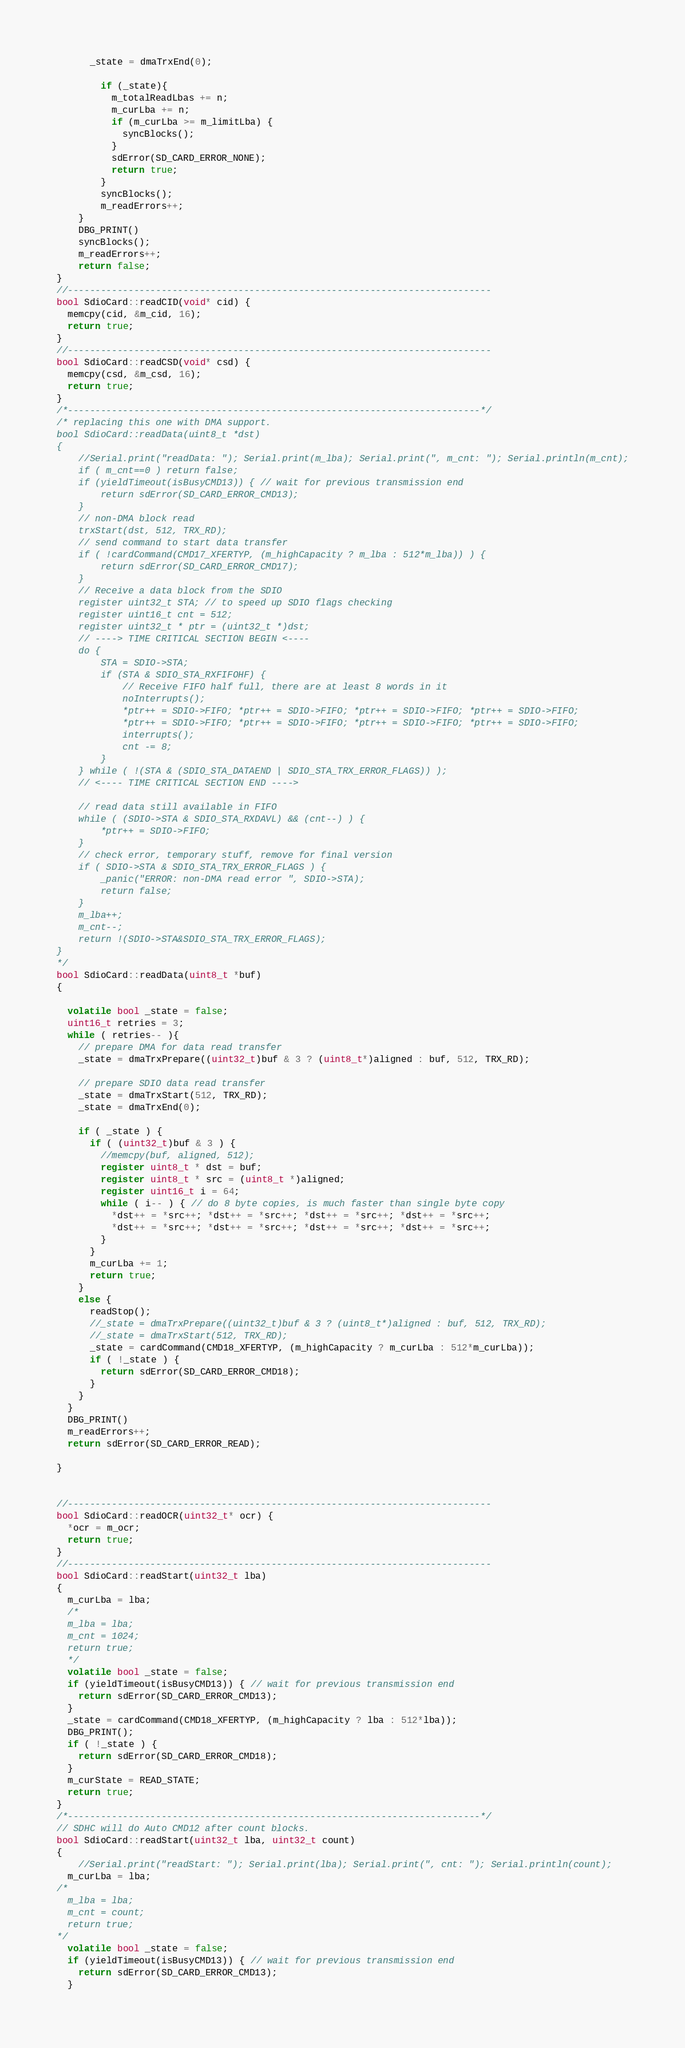Convert code to text. <code><loc_0><loc_0><loc_500><loc_500><_C++_>      _state = dmaTrxEnd(0);

        if (_state){
          m_totalReadLbas += n;
          m_curLba += n;
          if (m_curLba >= m_limitLba) {
            syncBlocks();
          }
          sdError(SD_CARD_ERROR_NONE);
          return true;
        }
        syncBlocks();
        m_readErrors++;
    }
    DBG_PRINT()
    syncBlocks();
    m_readErrors++;
    return false;
}
//-----------------------------------------------------------------------------
bool SdioCard::readCID(void* cid) {
  memcpy(cid, &m_cid, 16);
  return true;
}
//-----------------------------------------------------------------------------
bool SdioCard::readCSD(void* csd) {
  memcpy(csd, &m_csd, 16);
  return true;
}
/*---------------------------------------------------------------------------*/
/* replacing this one with DMA support.
bool SdioCard::readData(uint8_t *dst)
{
	//Serial.print("readData: "); Serial.print(m_lba); Serial.print(", m_cnt: "); Serial.println(m_cnt);
	if ( m_cnt==0 ) return false;
	if (yieldTimeout(isBusyCMD13)) { // wait for previous transmission end
		return sdError(SD_CARD_ERROR_CMD13);
	}
	// non-DMA block read
	trxStart(dst, 512, TRX_RD);
	// send command to start data transfer
	if ( !cardCommand(CMD17_XFERTYP, (m_highCapacity ? m_lba : 512*m_lba)) ) {
		return sdError(SD_CARD_ERROR_CMD17);
	}
	// Receive a data block from the SDIO
	register uint32_t STA; // to speed up SDIO flags checking
	register uint16_t cnt = 512;
	register uint32_t * ptr = (uint32_t *)dst;
	// ----> TIME CRITICAL SECTION BEGIN <----
	do {
		STA = SDIO->STA;
		if (STA & SDIO_STA_RXFIFOHF) {
			// Receive FIFO half full, there are at least 8 words in it
			noInterrupts();
			*ptr++ = SDIO->FIFO; *ptr++ = SDIO->FIFO; *ptr++ = SDIO->FIFO; *ptr++ = SDIO->FIFO;
			*ptr++ = SDIO->FIFO; *ptr++ = SDIO->FIFO; *ptr++ = SDIO->FIFO; *ptr++ = SDIO->FIFO;
			interrupts();
			cnt -= 8;
		}
	} while ( !(STA & (SDIO_STA_DATAEND | SDIO_STA_TRX_ERROR_FLAGS)) );
	// <---- TIME CRITICAL SECTION END ---->

	// read data still available in FIFO
	while ( (SDIO->STA & SDIO_STA_RXDAVL) && (cnt--) ) {
		*ptr++ = SDIO->FIFO;
	}
	// check error, temporary stuff, remove for final version
	if ( SDIO->STA & SDIO_STA_TRX_ERROR_FLAGS ) {
		_panic("ERROR: non-DMA read error ", SDIO->STA);
		return false;
	}
	m_lba++;
	m_cnt--;
	return !(SDIO->STA&SDIO_STA_TRX_ERROR_FLAGS);
}
*/
bool SdioCard::readData(uint8_t *buf)
{

  volatile bool _state = false;
  uint16_t retries = 3;
  while ( retries-- ){
    // prepare DMA for data read transfer
    _state = dmaTrxPrepare((uint32_t)buf & 3 ? (uint8_t*)aligned : buf, 512, TRX_RD);

    // prepare SDIO data read transfer
    _state = dmaTrxStart(512, TRX_RD);
    _state = dmaTrxEnd(0);

    if ( _state ) {
      if ( (uint32_t)buf & 3 ) {
        //memcpy(buf, aligned, 512);
        register uint8_t * dst = buf;
        register uint8_t * src = (uint8_t *)aligned;
        register uint16_t i = 64;
        while ( i-- ) { // do 8 byte copies, is much faster than single byte copy
          *dst++ = *src++; *dst++ = *src++; *dst++ = *src++; *dst++ = *src++;
          *dst++ = *src++; *dst++ = *src++; *dst++ = *src++; *dst++ = *src++;
        }
      }
      m_curLba += 1;
      return true;
    }
    else {
      readStop();
      //_state = dmaTrxPrepare((uint32_t)buf & 3 ? (uint8_t*)aligned : buf, 512, TRX_RD);
      //_state = dmaTrxStart(512, TRX_RD);
      _state = cardCommand(CMD18_XFERTYP, (m_highCapacity ? m_curLba : 512*m_curLba));
      if ( !_state ) {
        return sdError(SD_CARD_ERROR_CMD18);
      }
    }
  }
  DBG_PRINT()
  m_readErrors++;
  return sdError(SD_CARD_ERROR_READ);

}


//-----------------------------------------------------------------------------
bool SdioCard::readOCR(uint32_t* ocr) {
  *ocr = m_ocr;
  return true;
}
//-----------------------------------------------------------------------------
bool SdioCard::readStart(uint32_t lba)
{
  m_curLba = lba;
  /*
  m_lba = lba;
  m_cnt = 1024;
  return true;
  */
  volatile bool _state = false;
  if (yieldTimeout(isBusyCMD13)) { // wait for previous transmission end
    return sdError(SD_CARD_ERROR_CMD13);
  }
  _state = cardCommand(CMD18_XFERTYP, (m_highCapacity ? lba : 512*lba));
  DBG_PRINT();
  if ( !_state ) {
    return sdError(SD_CARD_ERROR_CMD18);
  }
  m_curState = READ_STATE;
  return true;
}
/*---------------------------------------------------------------------------*/
// SDHC will do Auto CMD12 after count blocks.
bool SdioCard::readStart(uint32_t lba, uint32_t count)
{
	//Serial.print("readStart: "); Serial.print(lba); Serial.print(", cnt: "); Serial.println(count);
  m_curLba = lba;
/*
  m_lba = lba;
  m_cnt = count;
  return true;
*/
  volatile bool _state = false;
  if (yieldTimeout(isBusyCMD13)) { // wait for previous transmission end
    return sdError(SD_CARD_ERROR_CMD13);
  }</code> 